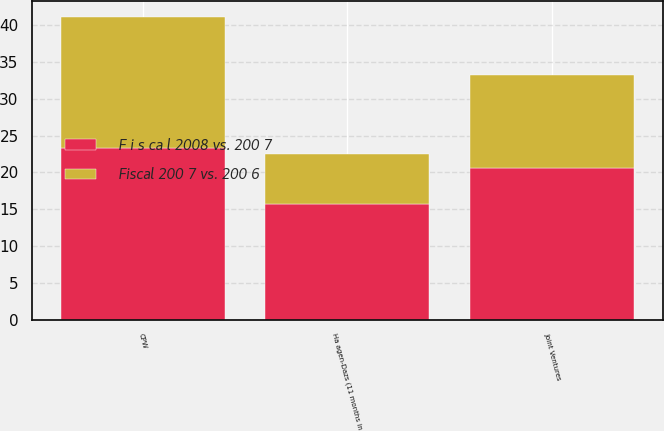<chart> <loc_0><loc_0><loc_500><loc_500><stacked_bar_chart><ecel><fcel>CPW<fcel>Ha agen-Dazs (11 months in<fcel>Joint Ventures<nl><fcel>F i s ca l 2008 vs. 200 7<fcel>23.3<fcel>15.7<fcel>20.6<nl><fcel>Fiscal 200 7 vs. 200 6<fcel>17.9<fcel>6.8<fcel>12.6<nl></chart> 